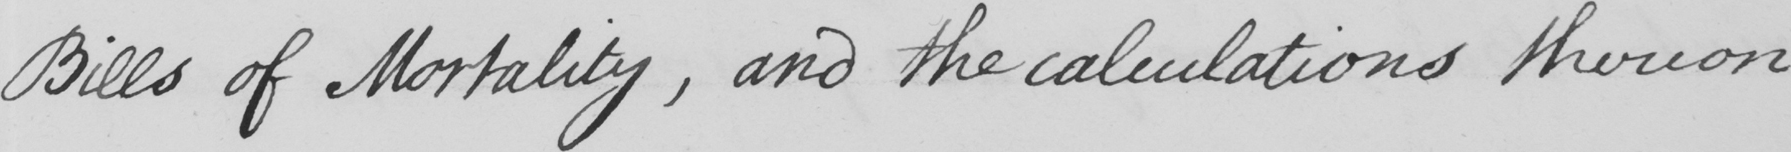Can you tell me what this handwritten text says? Bills of Mortality , and the calculations thereon 